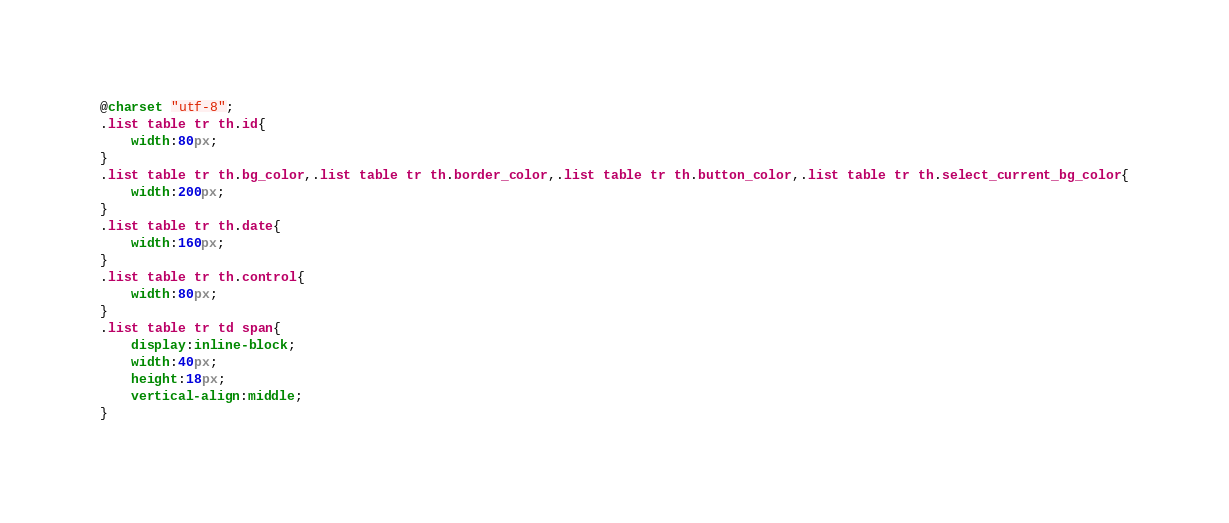<code> <loc_0><loc_0><loc_500><loc_500><_CSS_>@charset "utf-8";
.list table tr th.id{
	width:80px;
}
.list table tr th.bg_color,.list table tr th.border_color,.list table tr th.button_color,.list table tr th.select_current_bg_color{
	width:200px;
}
.list table tr th.date{
	width:160px;
}
.list table tr th.control{
	width:80px;
}
.list table tr td span{
	display:inline-block;
	width:40px;
	height:18px;
	vertical-align:middle;
}</code> 